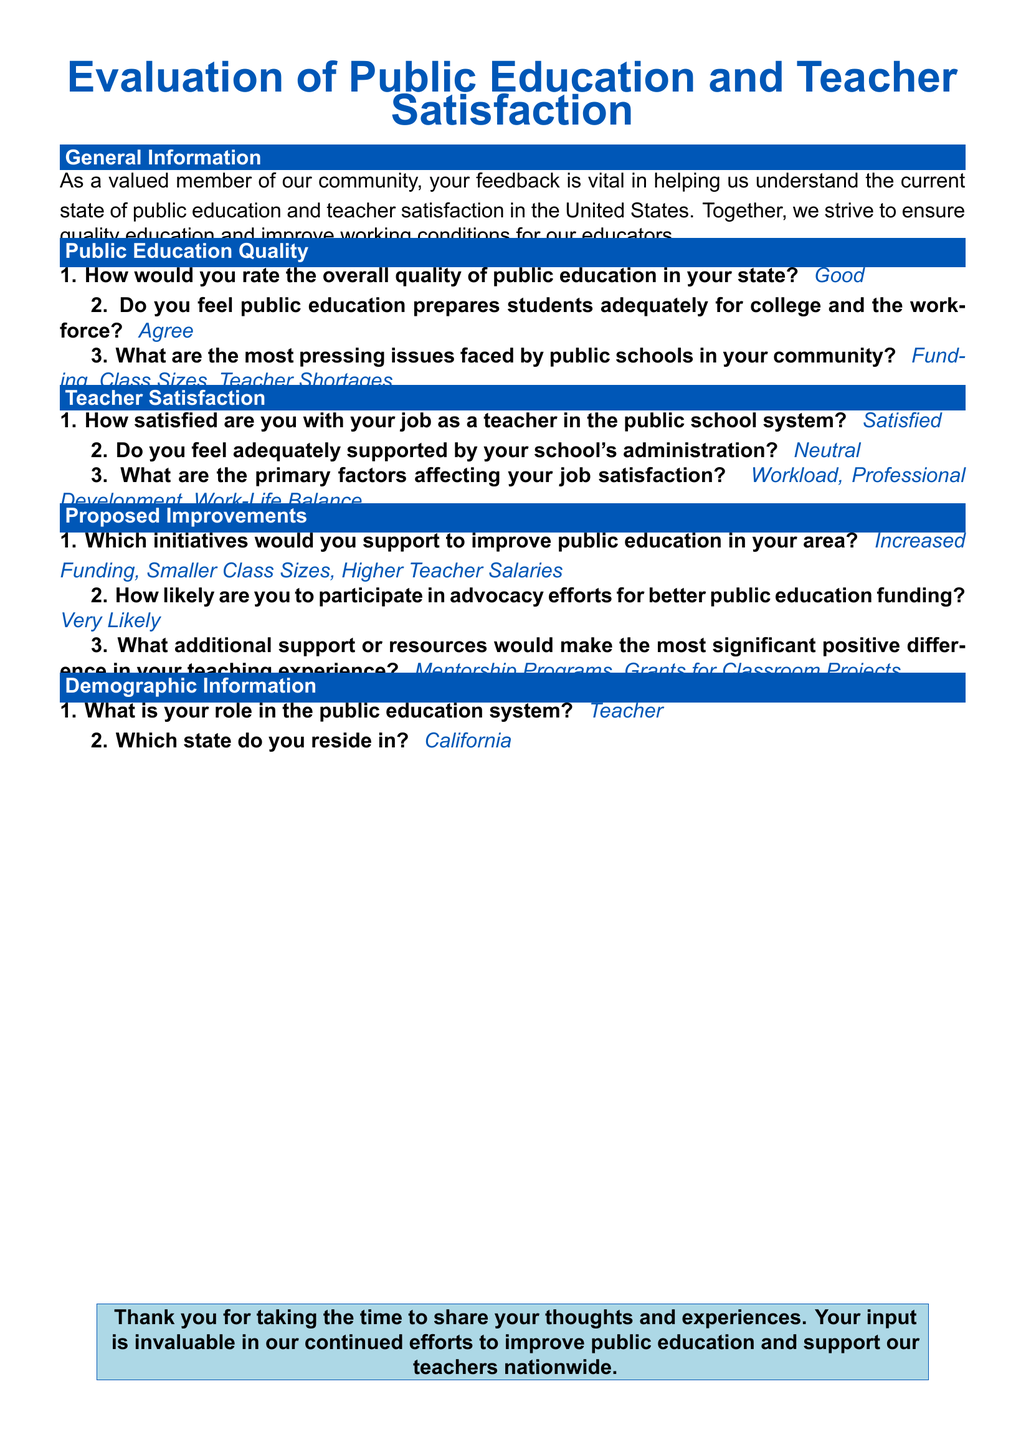What is the title of the survey? The title of the survey is prominently displayed at the top of the document.
Answer: Evaluation of Public Education and Teacher Satisfaction How many questions are in the Teacher Satisfaction section? The number of questions can be counted by reviewing the Teacher Satisfaction section.
Answer: 3 What is the main issue identified in the community for public schools? This can be found in the answer to the question regarding pressing issues faced by public schools.
Answer: Funding, Class Sizes, Teacher Shortages How satisfied are respondents with their job as a teacher? The satisfaction level is provided in the Teacher Satisfaction section of the document.
Answer: Satisfied What initiatives do respondents support for public education improvement? This is detailed in the Proposed Improvements section regarding support for initiatives.
Answer: Increased Funding, Smaller Class Sizes, Higher Teacher Salaries Which state does the respondent reside in? The response is given in the Demographic Information section of the survey.
Answer: California Do respondents feel adequately supported by school administration? This information can be found in the response to a specific question related to support from administration.
Answer: Neutral How likely are respondents to participate in advocacy efforts? This is summarized in the Proposed Improvements section where likelihood is queried.
Answer: Very Likely 